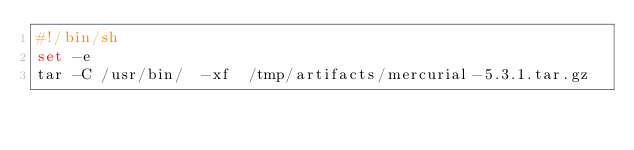<code> <loc_0><loc_0><loc_500><loc_500><_Bash_>#!/bin/sh
set -e
tar -C /usr/bin/  -xf  /tmp/artifacts/mercurial-5.3.1.tar.gz

</code> 